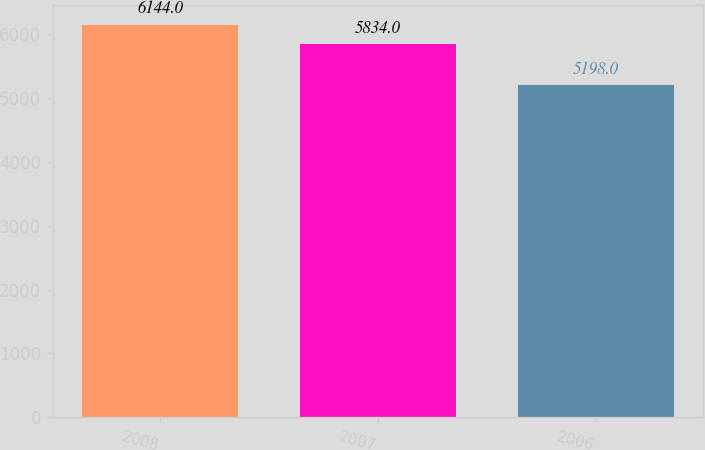Convert chart to OTSL. <chart><loc_0><loc_0><loc_500><loc_500><bar_chart><fcel>2008<fcel>2007<fcel>2006<nl><fcel>6144<fcel>5834<fcel>5198<nl></chart> 